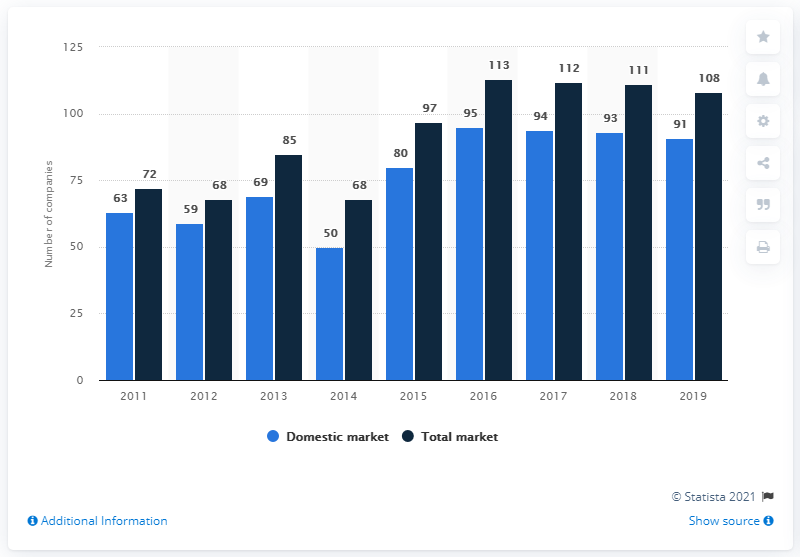Draw attention to some important aspects in this diagram. In 2019, there were 91 domestic insurance companies operating in Austria. 